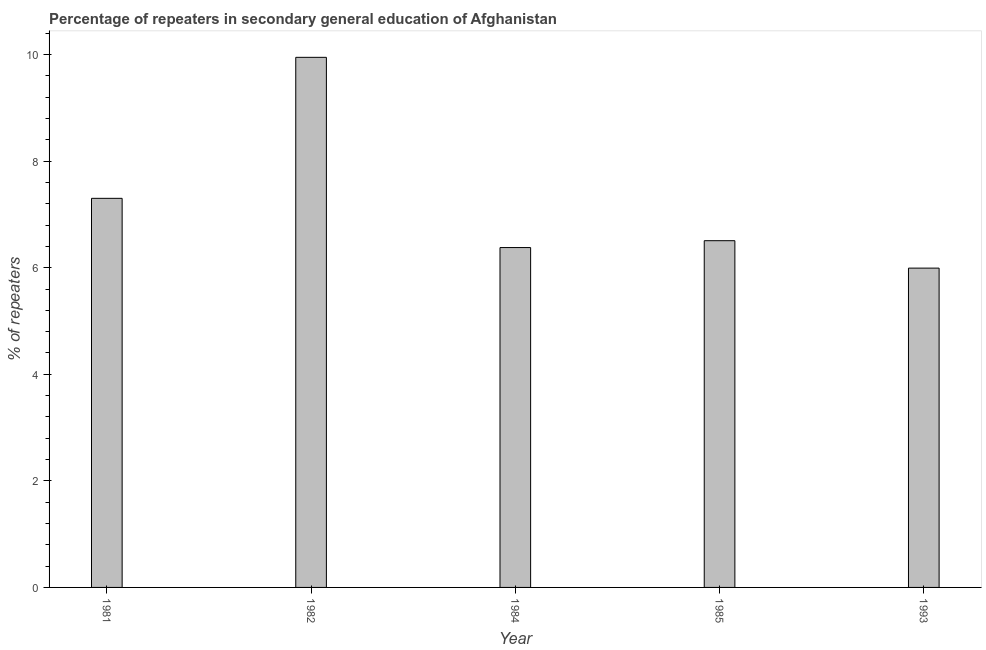What is the title of the graph?
Your answer should be compact. Percentage of repeaters in secondary general education of Afghanistan. What is the label or title of the X-axis?
Make the answer very short. Year. What is the label or title of the Y-axis?
Your response must be concise. % of repeaters. What is the percentage of repeaters in 1982?
Offer a very short reply. 9.95. Across all years, what is the maximum percentage of repeaters?
Your response must be concise. 9.95. Across all years, what is the minimum percentage of repeaters?
Provide a succinct answer. 5.99. In which year was the percentage of repeaters minimum?
Keep it short and to the point. 1993. What is the sum of the percentage of repeaters?
Keep it short and to the point. 36.13. What is the difference between the percentage of repeaters in 1982 and 1985?
Provide a short and direct response. 3.44. What is the average percentage of repeaters per year?
Give a very brief answer. 7.23. What is the median percentage of repeaters?
Your answer should be compact. 6.51. In how many years, is the percentage of repeaters greater than 3.2 %?
Keep it short and to the point. 5. Do a majority of the years between 1985 and 1982 (inclusive) have percentage of repeaters greater than 4.8 %?
Provide a short and direct response. Yes. What is the ratio of the percentage of repeaters in 1982 to that in 1984?
Offer a terse response. 1.56. Is the difference between the percentage of repeaters in 1981 and 1993 greater than the difference between any two years?
Your answer should be very brief. No. What is the difference between the highest and the second highest percentage of repeaters?
Your answer should be compact. 2.65. Is the sum of the percentage of repeaters in 1981 and 1985 greater than the maximum percentage of repeaters across all years?
Provide a short and direct response. Yes. What is the difference between the highest and the lowest percentage of repeaters?
Ensure brevity in your answer.  3.96. How many bars are there?
Your answer should be very brief. 5. Are all the bars in the graph horizontal?
Keep it short and to the point. No. How many years are there in the graph?
Keep it short and to the point. 5. What is the difference between two consecutive major ticks on the Y-axis?
Offer a very short reply. 2. Are the values on the major ticks of Y-axis written in scientific E-notation?
Provide a succinct answer. No. What is the % of repeaters in 1981?
Your answer should be compact. 7.3. What is the % of repeaters in 1982?
Keep it short and to the point. 9.95. What is the % of repeaters in 1984?
Offer a terse response. 6.38. What is the % of repeaters in 1985?
Offer a terse response. 6.51. What is the % of repeaters in 1993?
Provide a short and direct response. 5.99. What is the difference between the % of repeaters in 1981 and 1982?
Ensure brevity in your answer.  -2.65. What is the difference between the % of repeaters in 1981 and 1984?
Your response must be concise. 0.92. What is the difference between the % of repeaters in 1981 and 1985?
Make the answer very short. 0.79. What is the difference between the % of repeaters in 1981 and 1993?
Give a very brief answer. 1.31. What is the difference between the % of repeaters in 1982 and 1984?
Offer a very short reply. 3.57. What is the difference between the % of repeaters in 1982 and 1985?
Offer a very short reply. 3.44. What is the difference between the % of repeaters in 1982 and 1993?
Your answer should be compact. 3.96. What is the difference between the % of repeaters in 1984 and 1985?
Offer a terse response. -0.13. What is the difference between the % of repeaters in 1984 and 1993?
Your answer should be compact. 0.39. What is the difference between the % of repeaters in 1985 and 1993?
Keep it short and to the point. 0.51. What is the ratio of the % of repeaters in 1981 to that in 1982?
Ensure brevity in your answer.  0.73. What is the ratio of the % of repeaters in 1981 to that in 1984?
Provide a succinct answer. 1.15. What is the ratio of the % of repeaters in 1981 to that in 1985?
Make the answer very short. 1.12. What is the ratio of the % of repeaters in 1981 to that in 1993?
Provide a short and direct response. 1.22. What is the ratio of the % of repeaters in 1982 to that in 1984?
Keep it short and to the point. 1.56. What is the ratio of the % of repeaters in 1982 to that in 1985?
Give a very brief answer. 1.53. What is the ratio of the % of repeaters in 1982 to that in 1993?
Give a very brief answer. 1.66. What is the ratio of the % of repeaters in 1984 to that in 1985?
Give a very brief answer. 0.98. What is the ratio of the % of repeaters in 1984 to that in 1993?
Give a very brief answer. 1.06. What is the ratio of the % of repeaters in 1985 to that in 1993?
Keep it short and to the point. 1.09. 